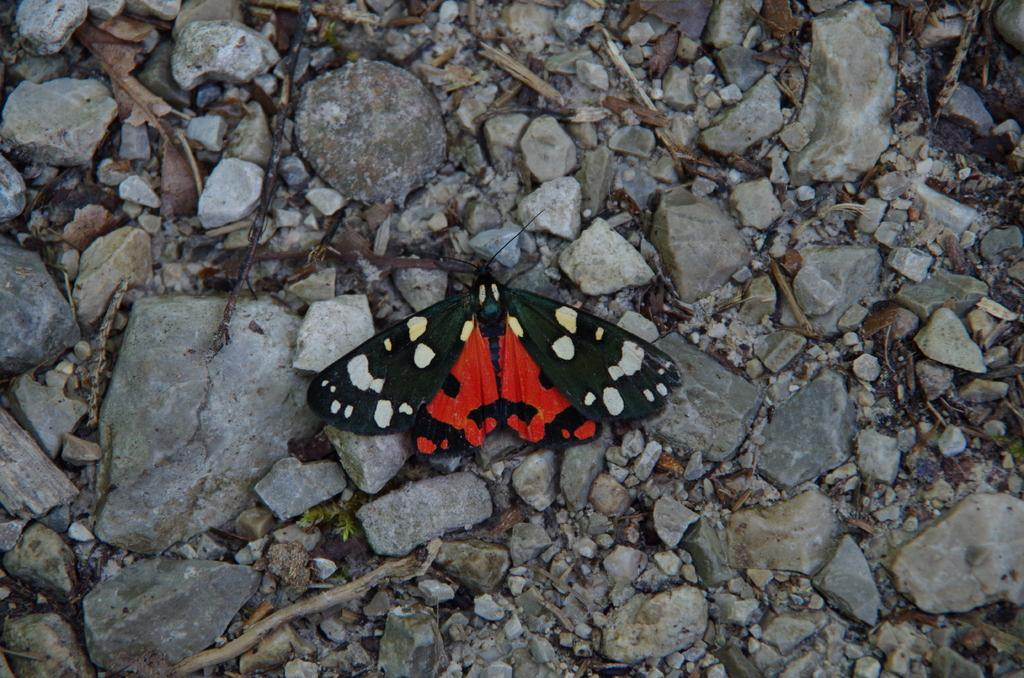What type of insect can be seen on the rocks in the image? There is a butterfly on the surface of the rocks in the image. What other objects can be seen in the image? There are wooden sticks and dry leaves present in the image. What type of riddle is depicted on the canvas in the image? There is no canvas or riddle present in the image. 